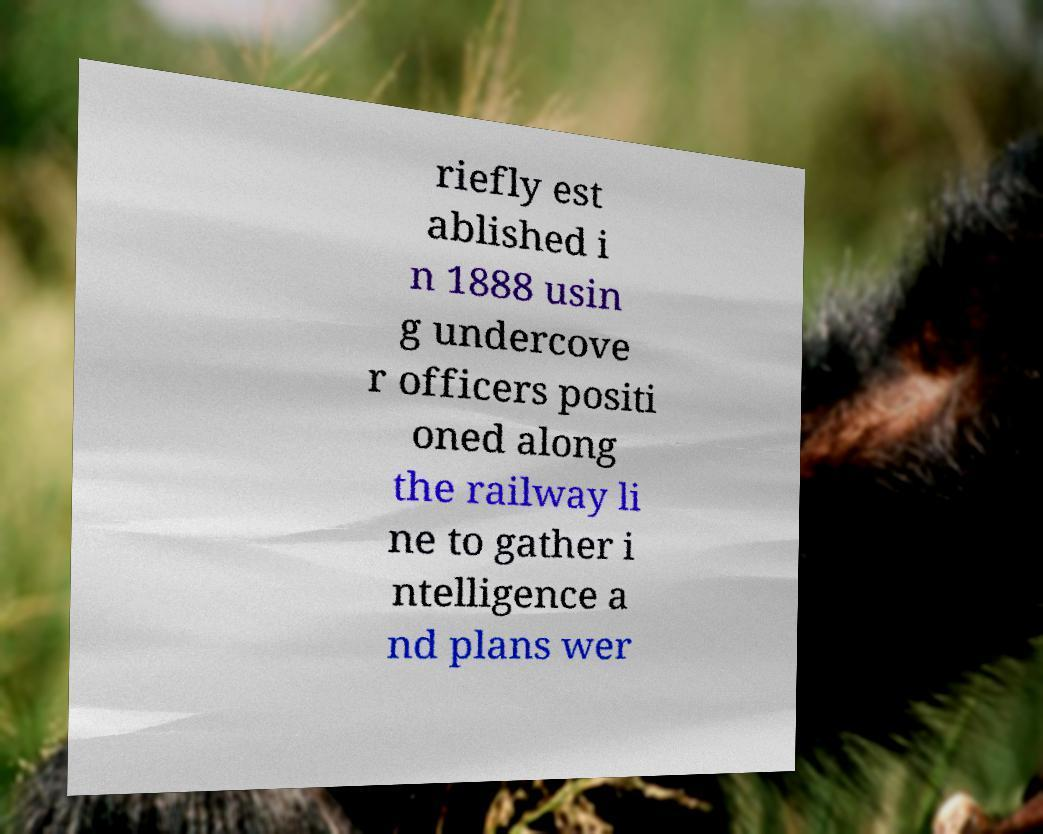For documentation purposes, I need the text within this image transcribed. Could you provide that? riefly est ablished i n 1888 usin g undercove r officers positi oned along the railway li ne to gather i ntelligence a nd plans wer 